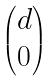Convert formula to latex. <formula><loc_0><loc_0><loc_500><loc_500>\begin{pmatrix} d \\ 0 \end{pmatrix}</formula> 